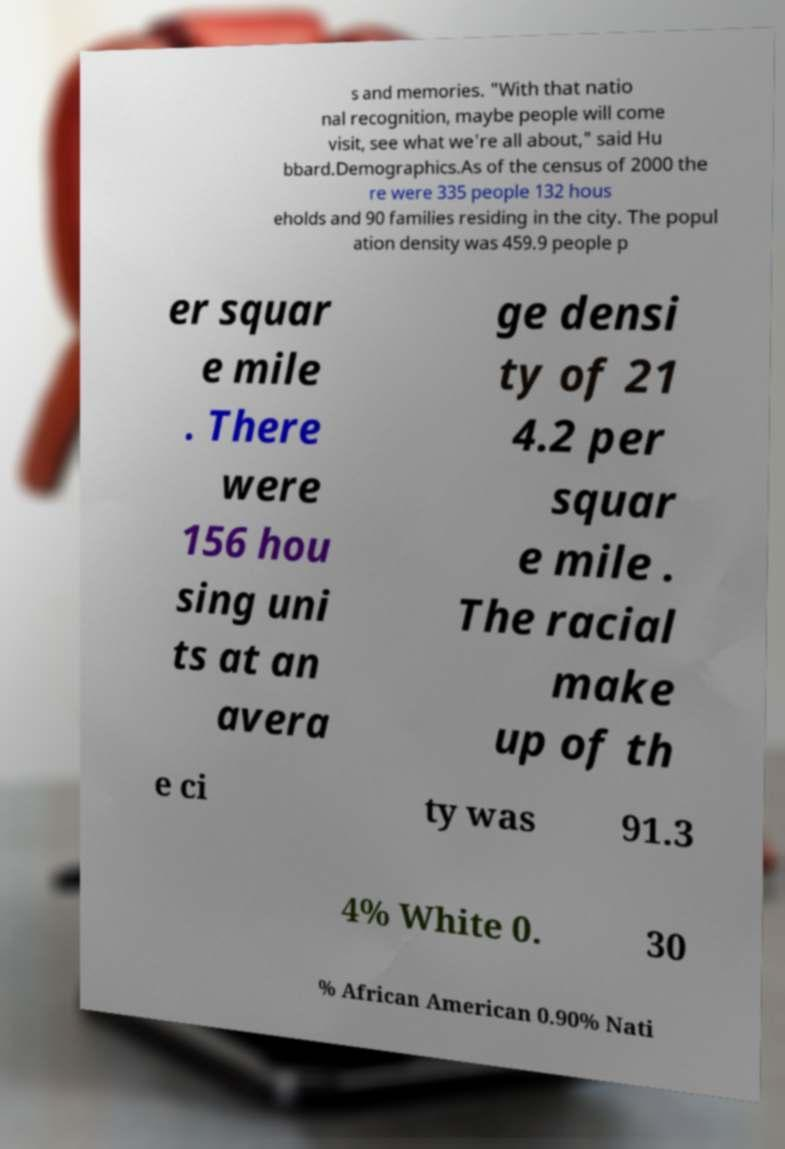Please read and relay the text visible in this image. What does it say? s and memories. "With that natio nal recognition, maybe people will come visit, see what we're all about," said Hu bbard.Demographics.As of the census of 2000 the re were 335 people 132 hous eholds and 90 families residing in the city. The popul ation density was 459.9 people p er squar e mile . There were 156 hou sing uni ts at an avera ge densi ty of 21 4.2 per squar e mile . The racial make up of th e ci ty was 91.3 4% White 0. 30 % African American 0.90% Nati 